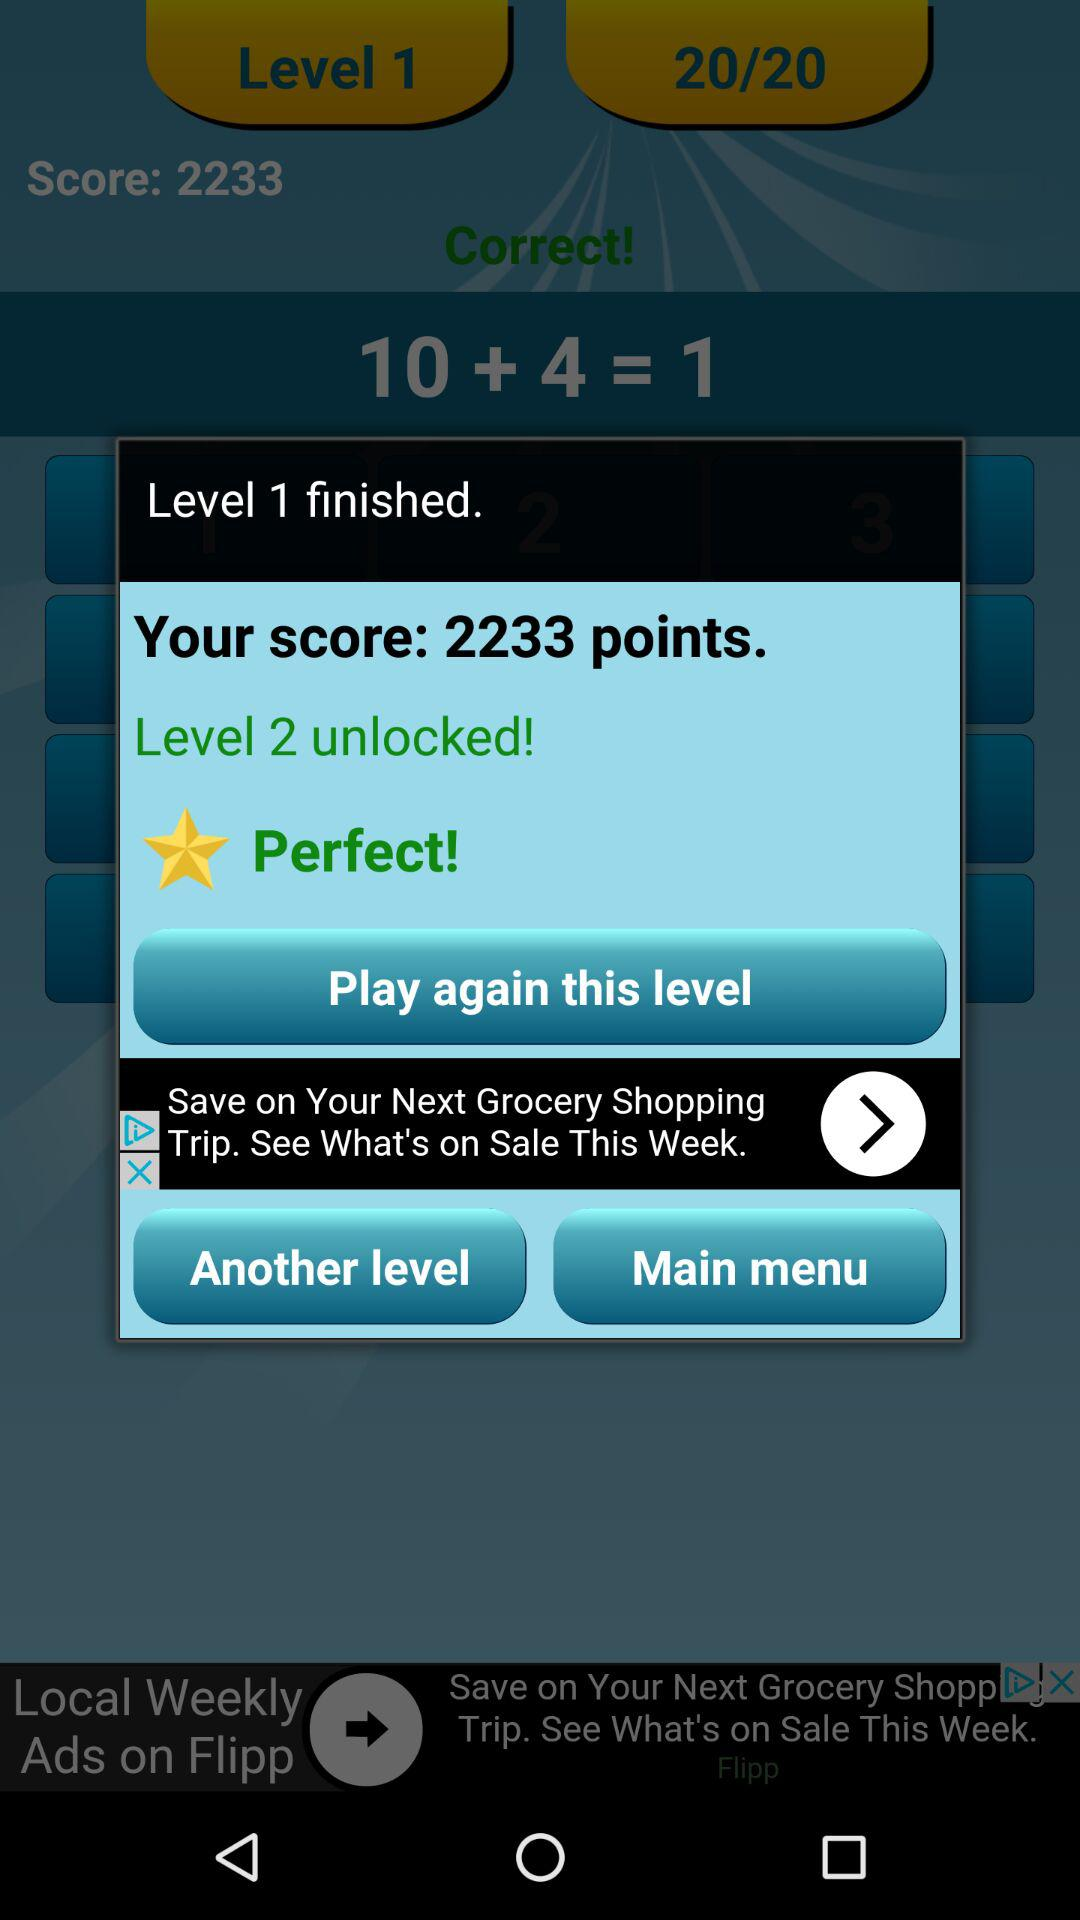Which level has been finished? The finished level is 1. 